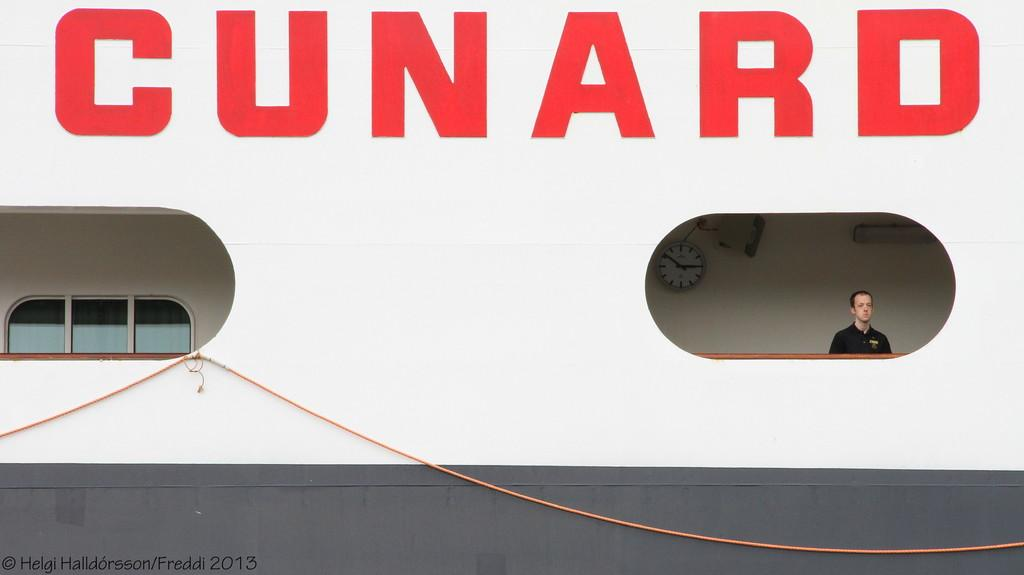What type of openings can be seen in the image? There are windows in the image. What object is used to measure time in the image? There is a clock in the image. What is the person in the image doing? The person is standing, possibly in a boat. What is the purpose of the rope in the image? The purpose of the rope is not clear from the facts provided, but it is visible in the image. What is written at the top of the image? There is text at the top of the image. Can you determine the time of day based on the image? The image might have been taken during the day, but the exact time cannot be determined. What type of art is being created during the rainstorm in the image? There is no rainstorm or art creation present in the image. What process is being used to create the art during the rainstorm in the image? There is no art creation or rainstorm present in the image, so no process can be identified. 